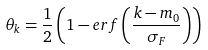<formula> <loc_0><loc_0><loc_500><loc_500>\theta _ { k } = \frac { 1 } { 2 } \left ( 1 - e r f \left ( \frac { k - m _ { 0 } } { \sigma _ { F } } \right ) \right )</formula> 